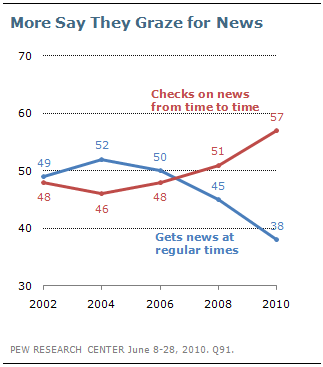Specify some key components in this picture. The average of the largest red data point and the leftmost blue data point is 53. In 2010, a graph with the highest number had a red color. 